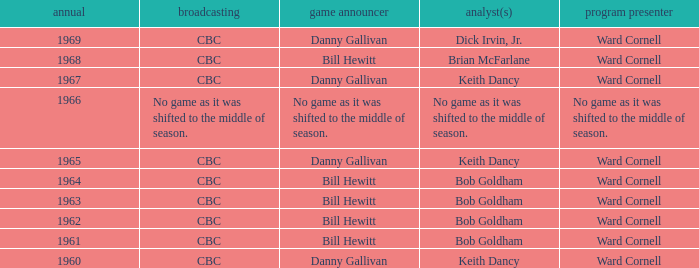Who gave the play by play commentary with studio host Ward Cornell? Danny Gallivan, Bill Hewitt, Danny Gallivan, Danny Gallivan, Bill Hewitt, Bill Hewitt, Bill Hewitt, Bill Hewitt, Danny Gallivan. 